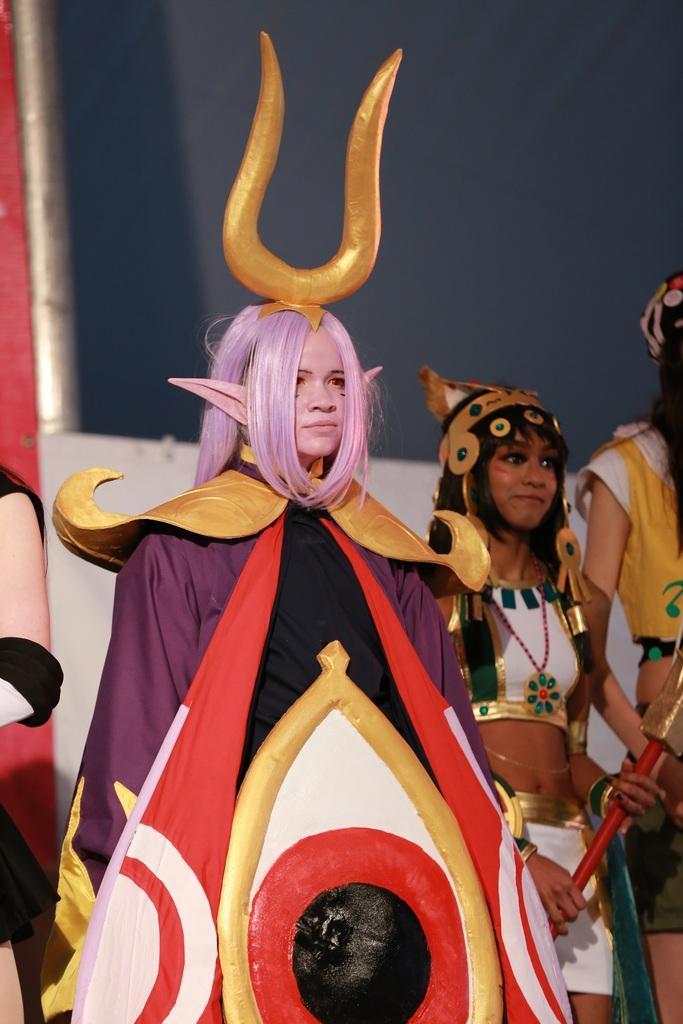Could you give a brief overview of what you see in this image? This image is taken indoors. In the background there is a wall. In the middle of the image a girl is standing and she has worn a weird costume. She has worn horns on her head. On the right side of the image there are two girls and a girl is holding a stick in her hands. On the left side of the image there is a person. 